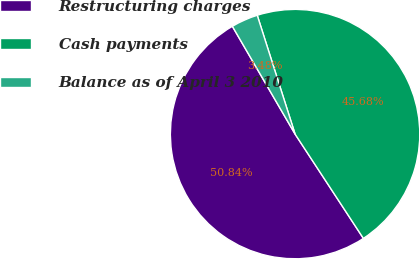<chart> <loc_0><loc_0><loc_500><loc_500><pie_chart><fcel>Restructuring charges<fcel>Cash payments<fcel>Balance as of April 3 2010<nl><fcel>50.84%<fcel>45.68%<fcel>3.48%<nl></chart> 